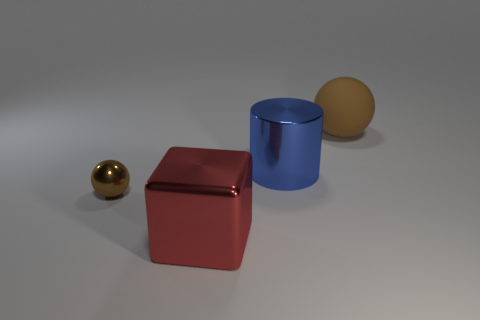Add 4 shiny objects. How many objects exist? 8 Subtract 1 blocks. How many blocks are left? 0 Subtract all blocks. How many objects are left? 3 Subtract all cylinders. Subtract all tiny blue rubber objects. How many objects are left? 3 Add 4 small balls. How many small balls are left? 5 Add 1 large metal things. How many large metal things exist? 3 Subtract 0 gray cylinders. How many objects are left? 4 Subtract all yellow cylinders. Subtract all red cubes. How many cylinders are left? 1 